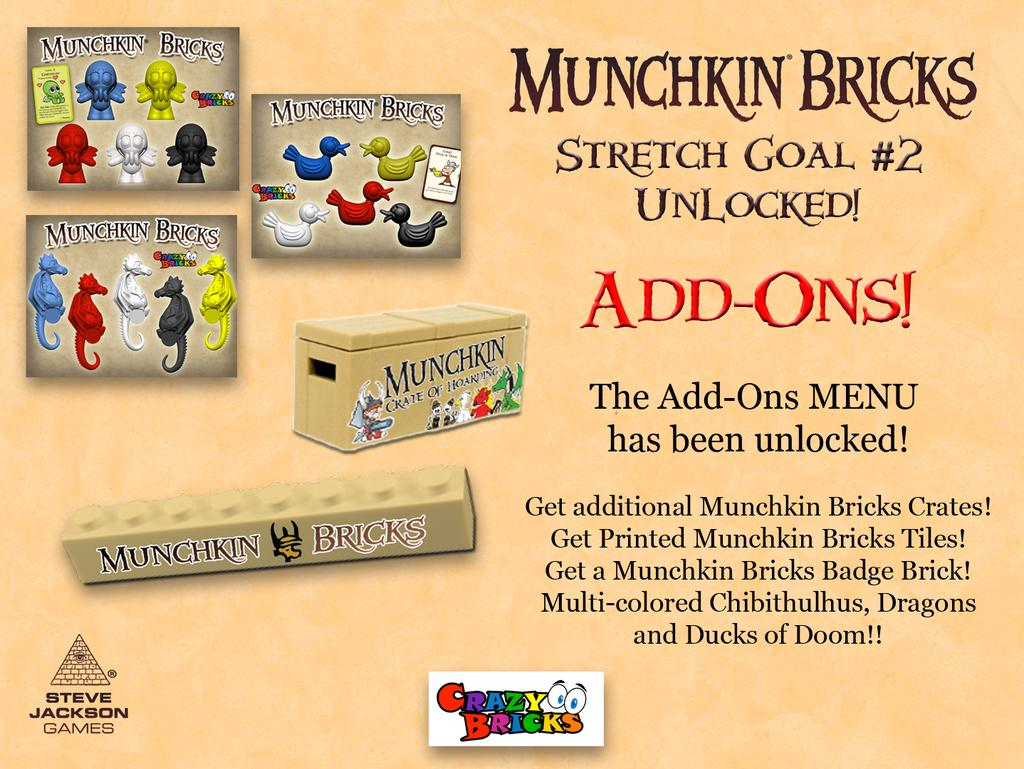<image>
Create a compact narrative representing the image presented. A bunch of different Munchkin Brick boxes near each other 